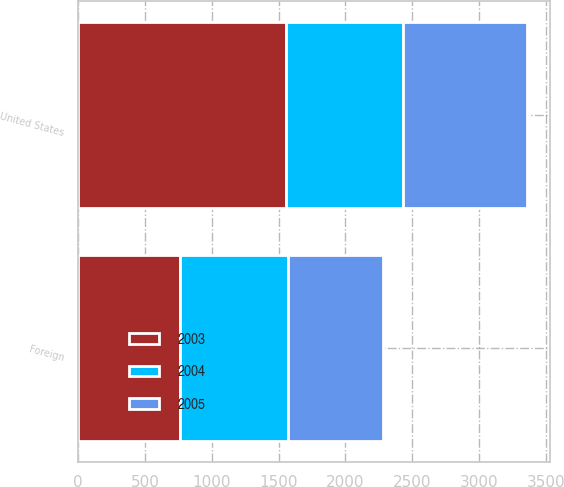Convert chart to OTSL. <chart><loc_0><loc_0><loc_500><loc_500><stacked_bar_chart><ecel><fcel>United States<fcel>Foreign<nl><fcel>2003<fcel>1557<fcel>766<nl><fcel>2004<fcel>878<fcel>802<nl><fcel>2005<fcel>925<fcel>715<nl></chart> 